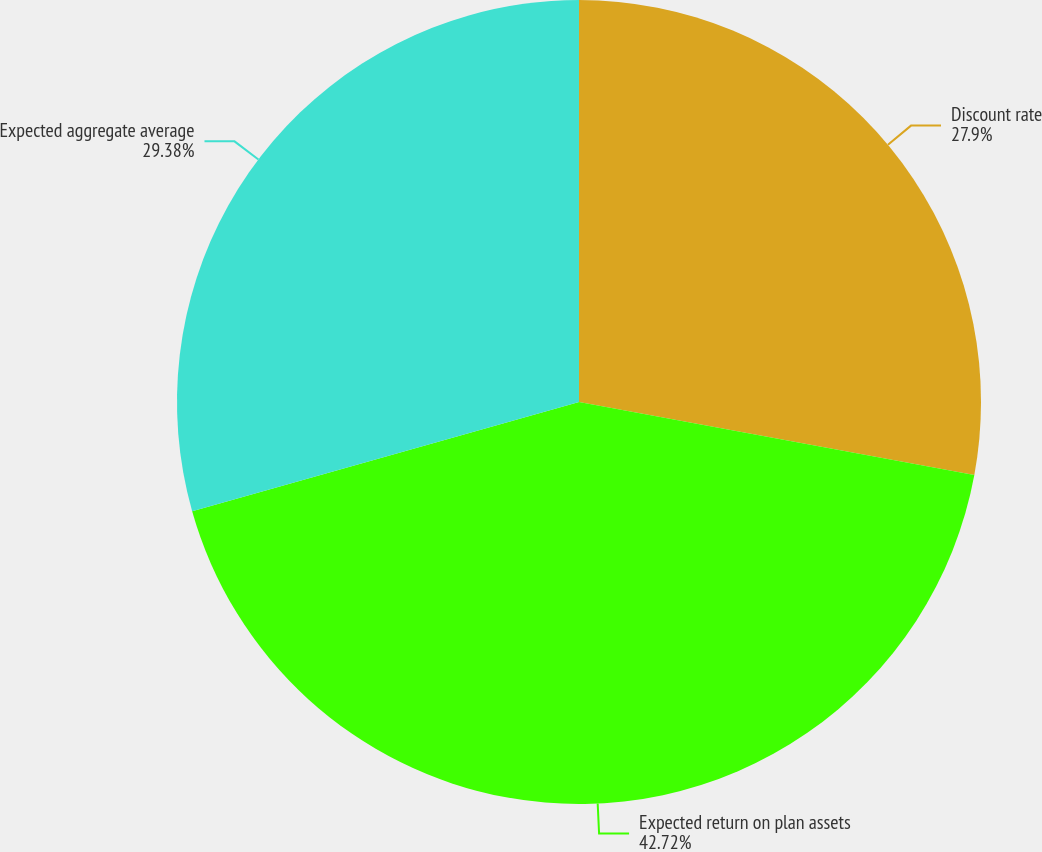Convert chart to OTSL. <chart><loc_0><loc_0><loc_500><loc_500><pie_chart><fcel>Discount rate<fcel>Expected return on plan assets<fcel>Expected aggregate average<nl><fcel>27.9%<fcel>42.71%<fcel>29.38%<nl></chart> 